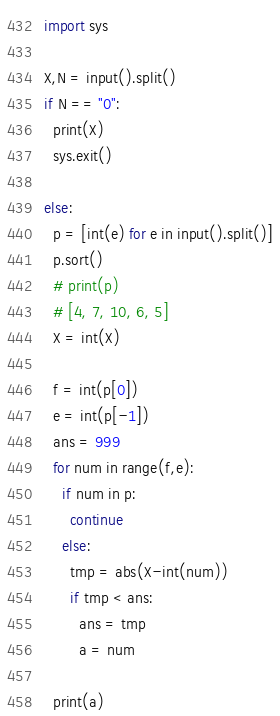Convert code to text. <code><loc_0><loc_0><loc_500><loc_500><_Python_>import sys

X,N = input().split()
if N == "0":
  print(X)
  sys.exit()

else:
  p = [int(e) for e in input().split()]
  p.sort()
  # print(p)
  # [4, 7, 10, 6, 5]
  X = int(X)

  f = int(p[0])
  e = int(p[-1])
  ans = 999
  for num in range(f,e):
    if num in p:
      continue
    else:
      tmp = abs(X-int(num))
      if tmp < ans:
        ans = tmp
        a = num

  print(a)</code> 